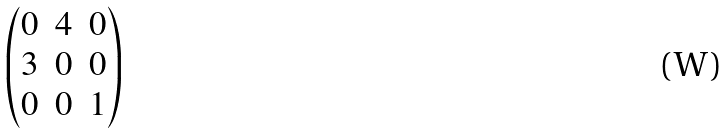Convert formula to latex. <formula><loc_0><loc_0><loc_500><loc_500>\begin{pmatrix} 0 & 4 & 0 \\ 3 & 0 & 0 \\ 0 & 0 & 1 \end{pmatrix}</formula> 